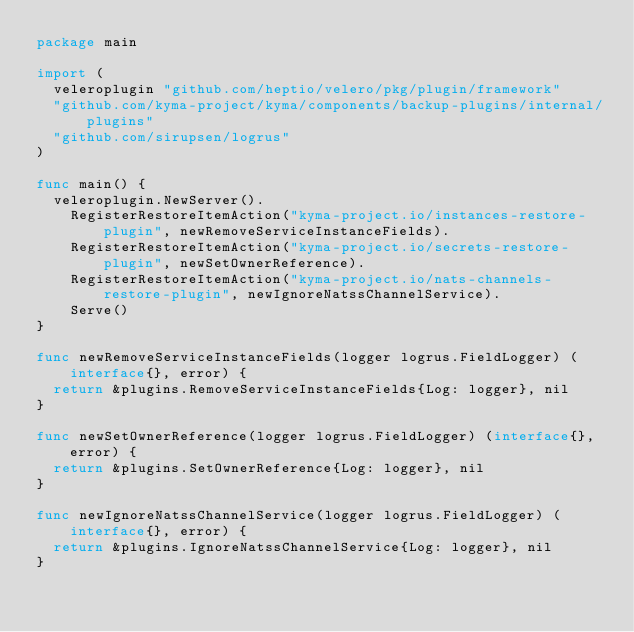<code> <loc_0><loc_0><loc_500><loc_500><_Go_>package main

import (
	veleroplugin "github.com/heptio/velero/pkg/plugin/framework"
	"github.com/kyma-project/kyma/components/backup-plugins/internal/plugins"
	"github.com/sirupsen/logrus"
)

func main() {
	veleroplugin.NewServer().
		RegisterRestoreItemAction("kyma-project.io/instances-restore-plugin", newRemoveServiceInstanceFields).
		RegisterRestoreItemAction("kyma-project.io/secrets-restore-plugin", newSetOwnerReference).
		RegisterRestoreItemAction("kyma-project.io/nats-channels-restore-plugin", newIgnoreNatssChannelService).
		Serve()
}

func newRemoveServiceInstanceFields(logger logrus.FieldLogger) (interface{}, error) {
	return &plugins.RemoveServiceInstanceFields{Log: logger}, nil
}

func newSetOwnerReference(logger logrus.FieldLogger) (interface{}, error) {
	return &plugins.SetOwnerReference{Log: logger}, nil
}

func newIgnoreNatssChannelService(logger logrus.FieldLogger) (interface{}, error) {
	return &plugins.IgnoreNatssChannelService{Log: logger}, nil
}
</code> 